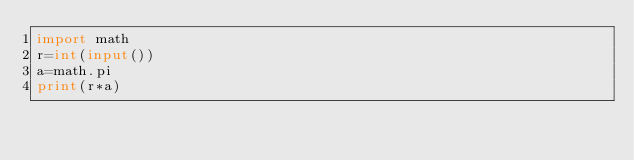Convert code to text. <code><loc_0><loc_0><loc_500><loc_500><_Python_>import math
r=int(input())
a=math.pi
print(r*a)
</code> 